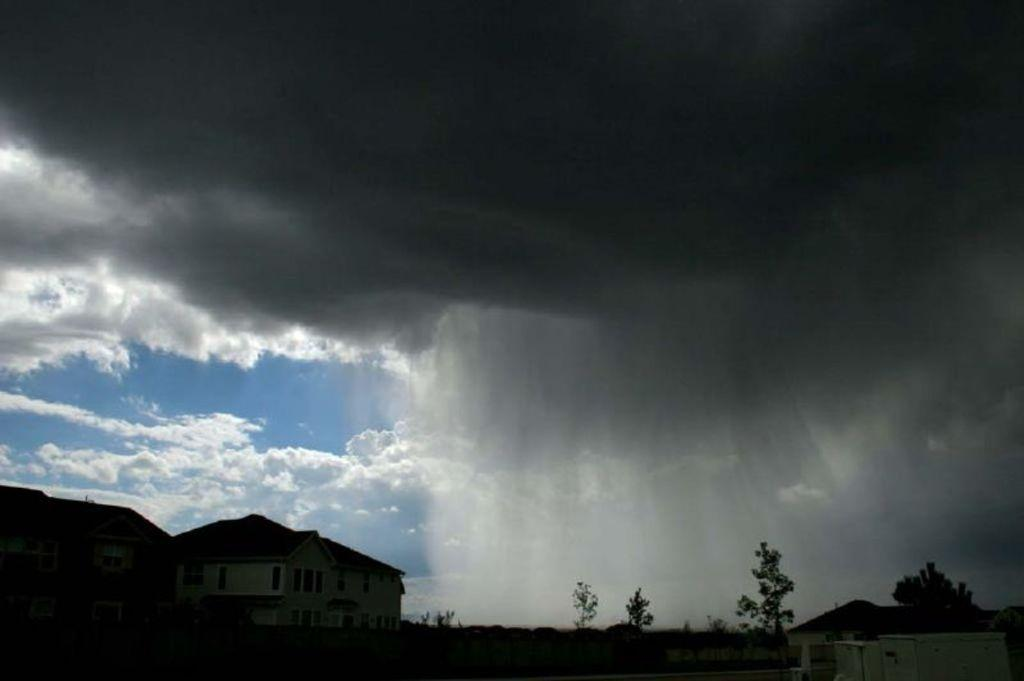What types of structures are located at the bottom of the image? There are buildings at the bottom of the image. What else can be seen at the bottom of the image? There are trees at the bottom of the image. What is present in the middle of the image? There are clouds in the middle of the image, and sky is also visible. Can you see a spark coming from the trees in the image? There is no spark present in the image; it features buildings, trees, clouds, and sky. Is there a crown visible on top of the clouds in the image? There is no crown present in the image; it only features buildings, trees, clouds, and sky. 